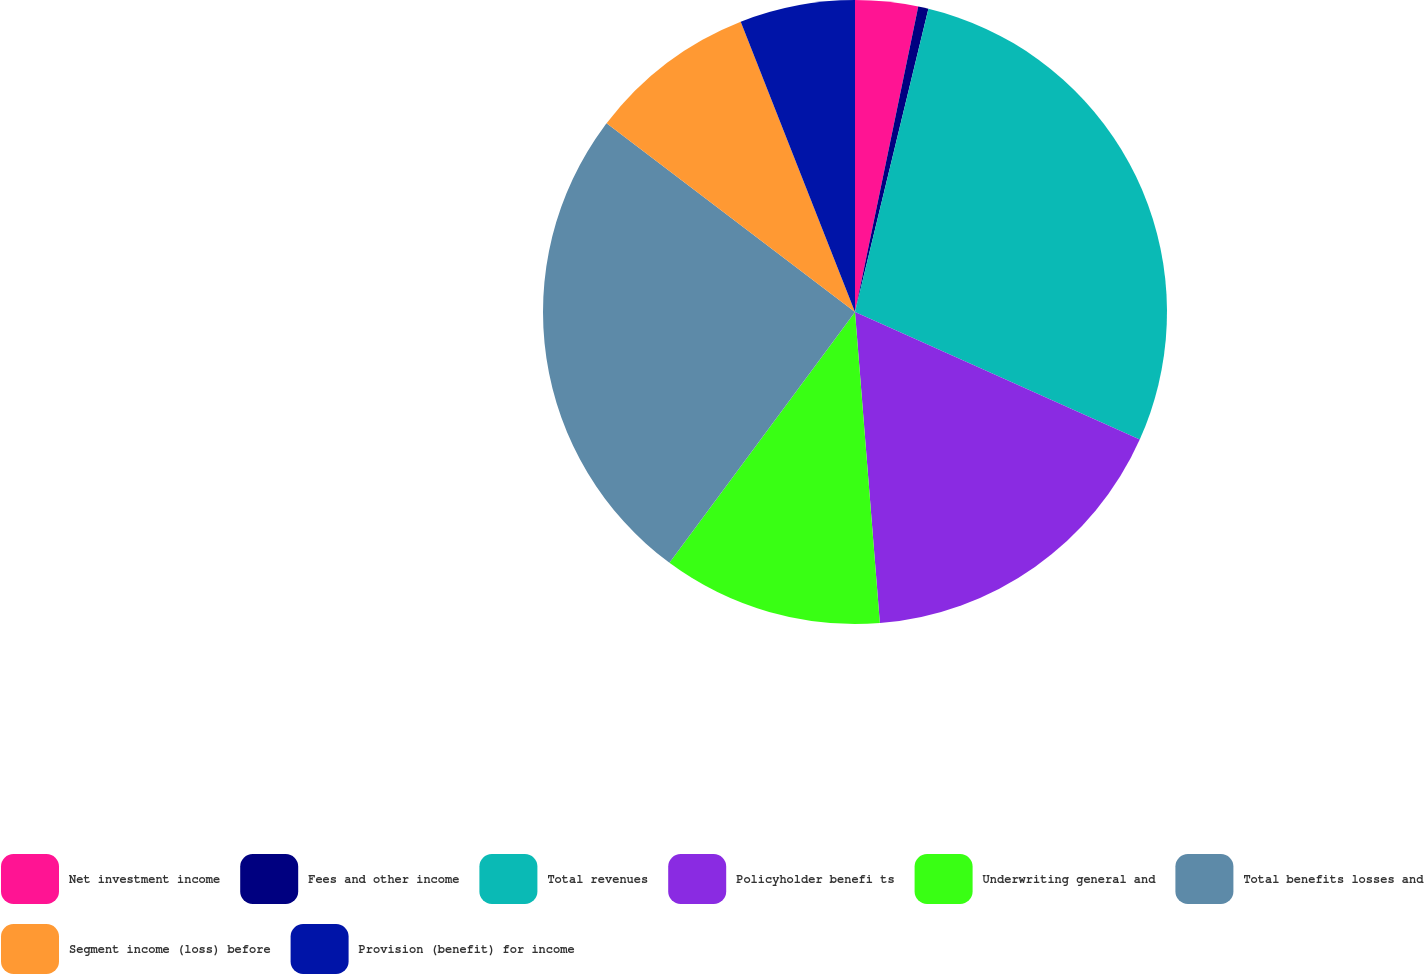Convert chart. <chart><loc_0><loc_0><loc_500><loc_500><pie_chart><fcel>Net investment income<fcel>Fees and other income<fcel>Total revenues<fcel>Policyholder benefi ts<fcel>Underwriting general and<fcel>Total benefits losses and<fcel>Segment income (loss) before<fcel>Provision (benefit) for income<nl><fcel>3.25%<fcel>0.53%<fcel>27.93%<fcel>17.03%<fcel>11.41%<fcel>25.21%<fcel>8.69%<fcel>5.97%<nl></chart> 